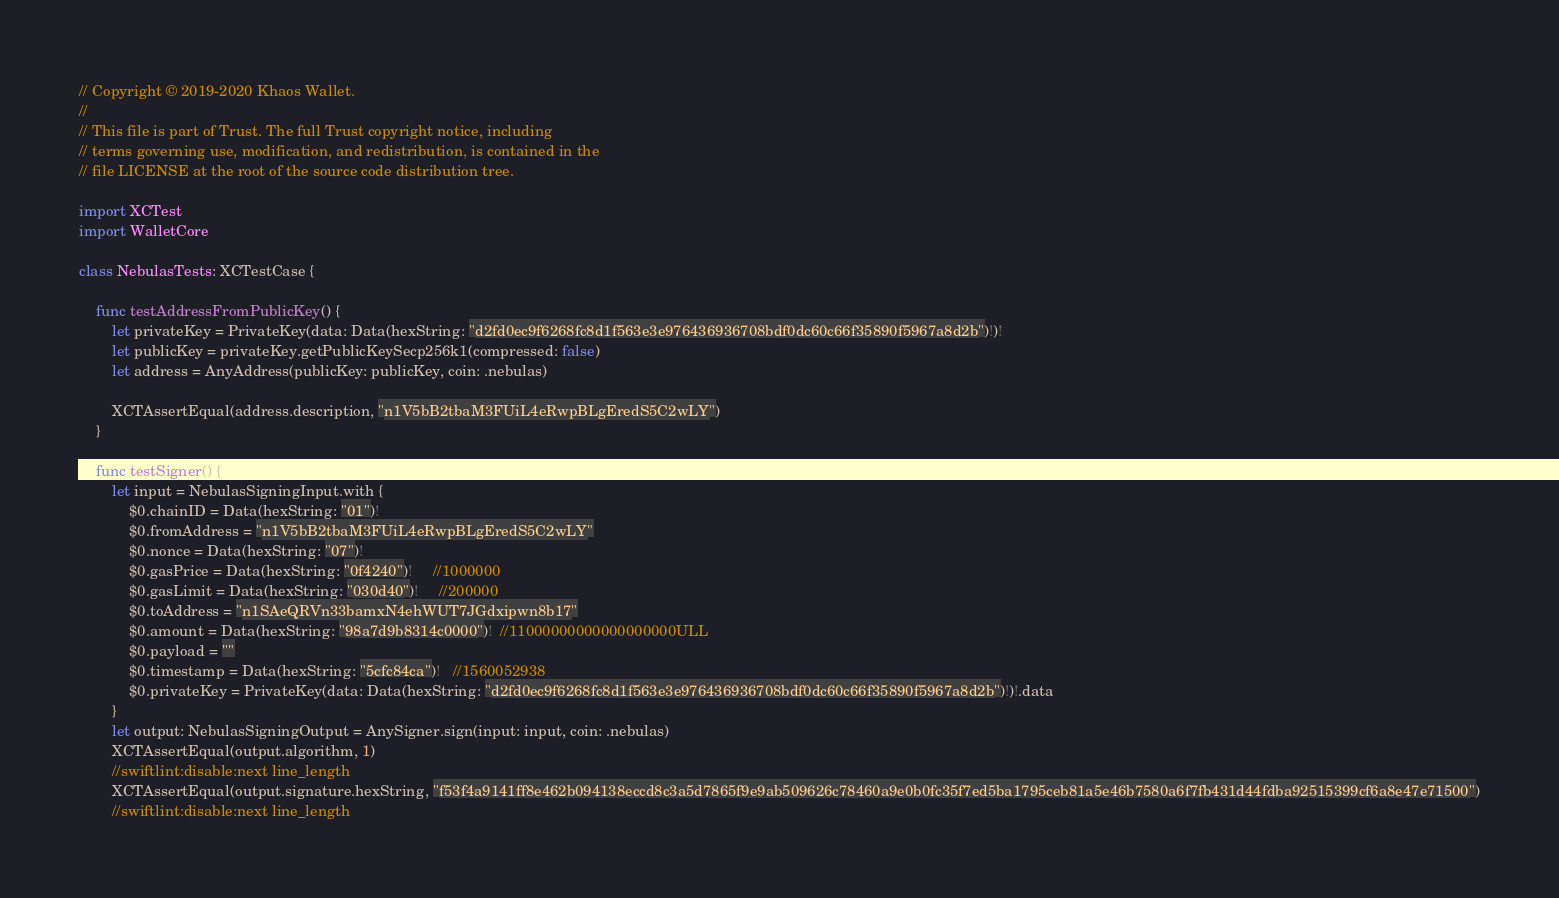Convert code to text. <code><loc_0><loc_0><loc_500><loc_500><_Swift_>// Copyright © 2019-2020 Khaos Wallet.
//
// This file is part of Trust. The full Trust copyright notice, including
// terms governing use, modification, and redistribution, is contained in the
// file LICENSE at the root of the source code distribution tree.

import XCTest
import WalletCore

class NebulasTests: XCTestCase {

    func testAddressFromPublicKey() {
        let privateKey = PrivateKey(data: Data(hexString: "d2fd0ec9f6268fc8d1f563e3e976436936708bdf0dc60c66f35890f5967a8d2b")!)!
        let publicKey = privateKey.getPublicKeySecp256k1(compressed: false)
        let address = AnyAddress(publicKey: publicKey, coin: .nebulas)

        XCTAssertEqual(address.description, "n1V5bB2tbaM3FUiL4eRwpBLgEredS5C2wLY")
    }

    func testSigner() {
        let input = NebulasSigningInput.with {
            $0.chainID = Data(hexString: "01")!
            $0.fromAddress = "n1V5bB2tbaM3FUiL4eRwpBLgEredS5C2wLY"
            $0.nonce = Data(hexString: "07")!
            $0.gasPrice = Data(hexString: "0f4240")!     //1000000
            $0.gasLimit = Data(hexString: "030d40")!     //200000
            $0.toAddress = "n1SAeQRVn33bamxN4ehWUT7JGdxipwn8b17"
            $0.amount = Data(hexString: "98a7d9b8314c0000")!  //11000000000000000000ULL
            $0.payload = ""
            $0.timestamp = Data(hexString: "5cfc84ca")!   //1560052938
            $0.privateKey = PrivateKey(data: Data(hexString: "d2fd0ec9f6268fc8d1f563e3e976436936708bdf0dc60c66f35890f5967a8d2b")!)!.data
        }
        let output: NebulasSigningOutput = AnySigner.sign(input: input, coin: .nebulas)
        XCTAssertEqual(output.algorithm, 1)
        //swiftlint:disable:next line_length
        XCTAssertEqual(output.signature.hexString, "f53f4a9141ff8e462b094138eccd8c3a5d7865f9e9ab509626c78460a9e0b0fc35f7ed5ba1795ceb81a5e46b7580a6f7fb431d44fdba92515399cf6a8e47e71500")
        //swiftlint:disable:next line_length</code> 